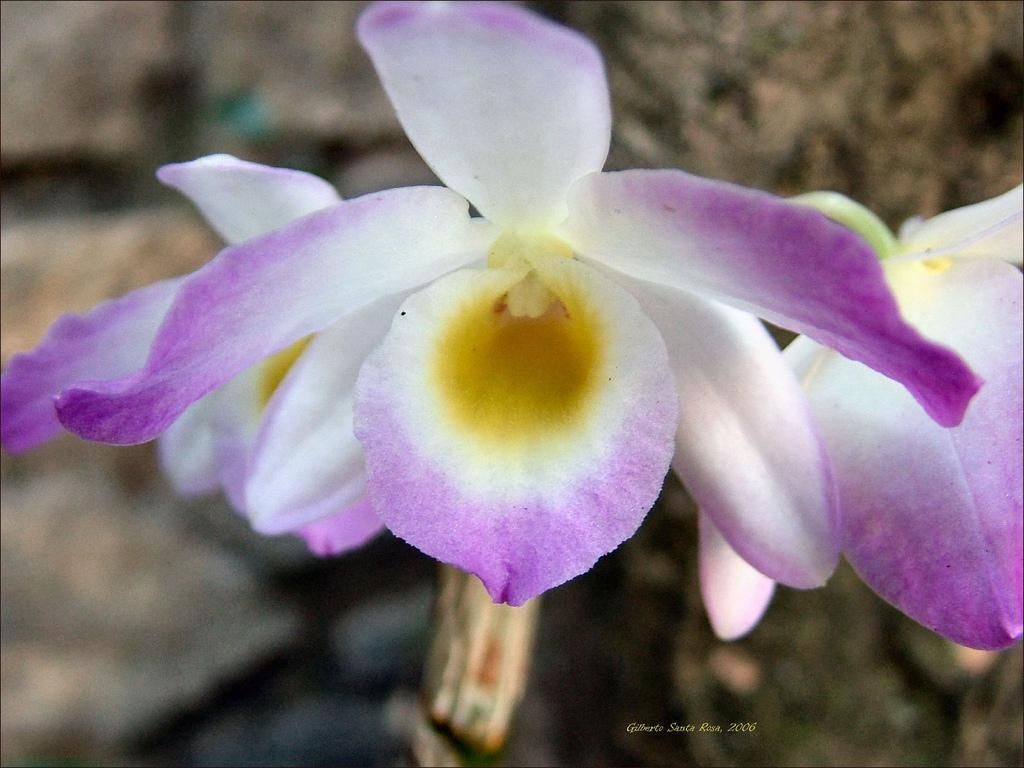What type of living organisms can be seen in the image? There are flowers in the image. How would you describe the background of the image? The background of the image is blurred. Is there any text present in the image? Yes, there is text at the bottom of the image. What type of letter is being ploughed into the field in the image? There is no letter or field present in the image; it features flowers and a blurred background. What type of education can be seen being provided in the image? There is no educational activity depicted in the image; it features flowers, a blurred background, and text at the bottom. 